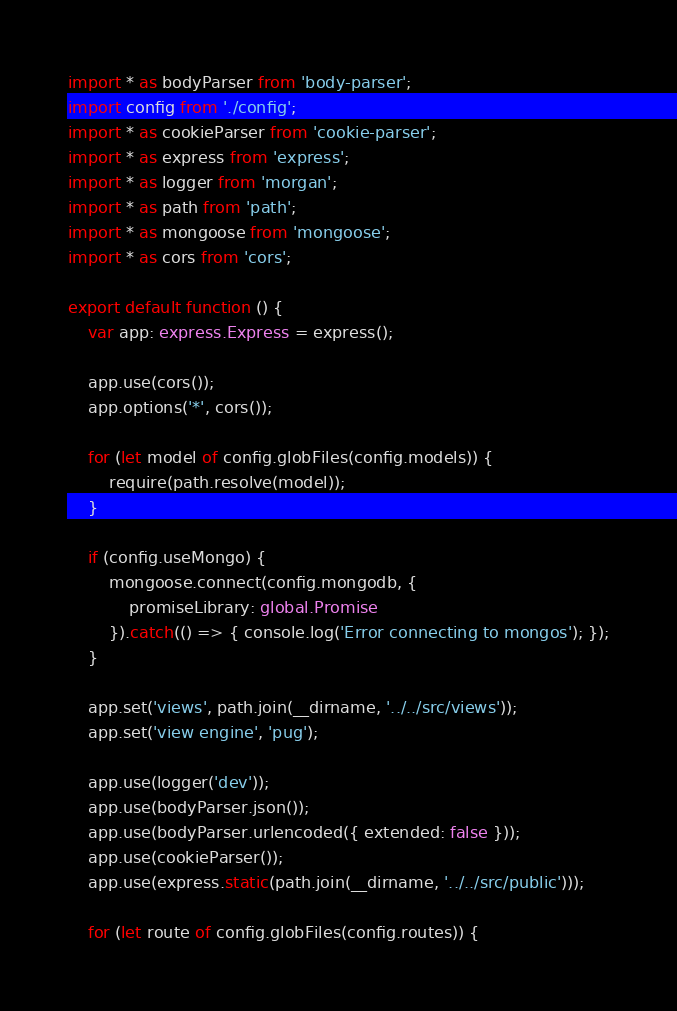Convert code to text. <code><loc_0><loc_0><loc_500><loc_500><_TypeScript_>import * as bodyParser from 'body-parser';
import config from './config';
import * as cookieParser from 'cookie-parser';
import * as express from 'express';
import * as logger from 'morgan';
import * as path from 'path';
import * as mongoose from 'mongoose';
import * as cors from 'cors';

export default function () {
    var app: express.Express = express();

    app.use(cors());
    app.options('*', cors());

    for (let model of config.globFiles(config.models)) {
        require(path.resolve(model));
    }

    if (config.useMongo) {
        mongoose.connect(config.mongodb, {
            promiseLibrary: global.Promise
        }).catch(() => { console.log('Error connecting to mongos'); });
    }

    app.set('views', path.join(__dirname, '../../src/views'));
    app.set('view engine', 'pug');

    app.use(logger('dev'));
    app.use(bodyParser.json());
    app.use(bodyParser.urlencoded({ extended: false }));
    app.use(cookieParser());
    app.use(express.static(path.join(__dirname, '../../src/public')));

    for (let route of config.globFiles(config.routes)) {</code> 